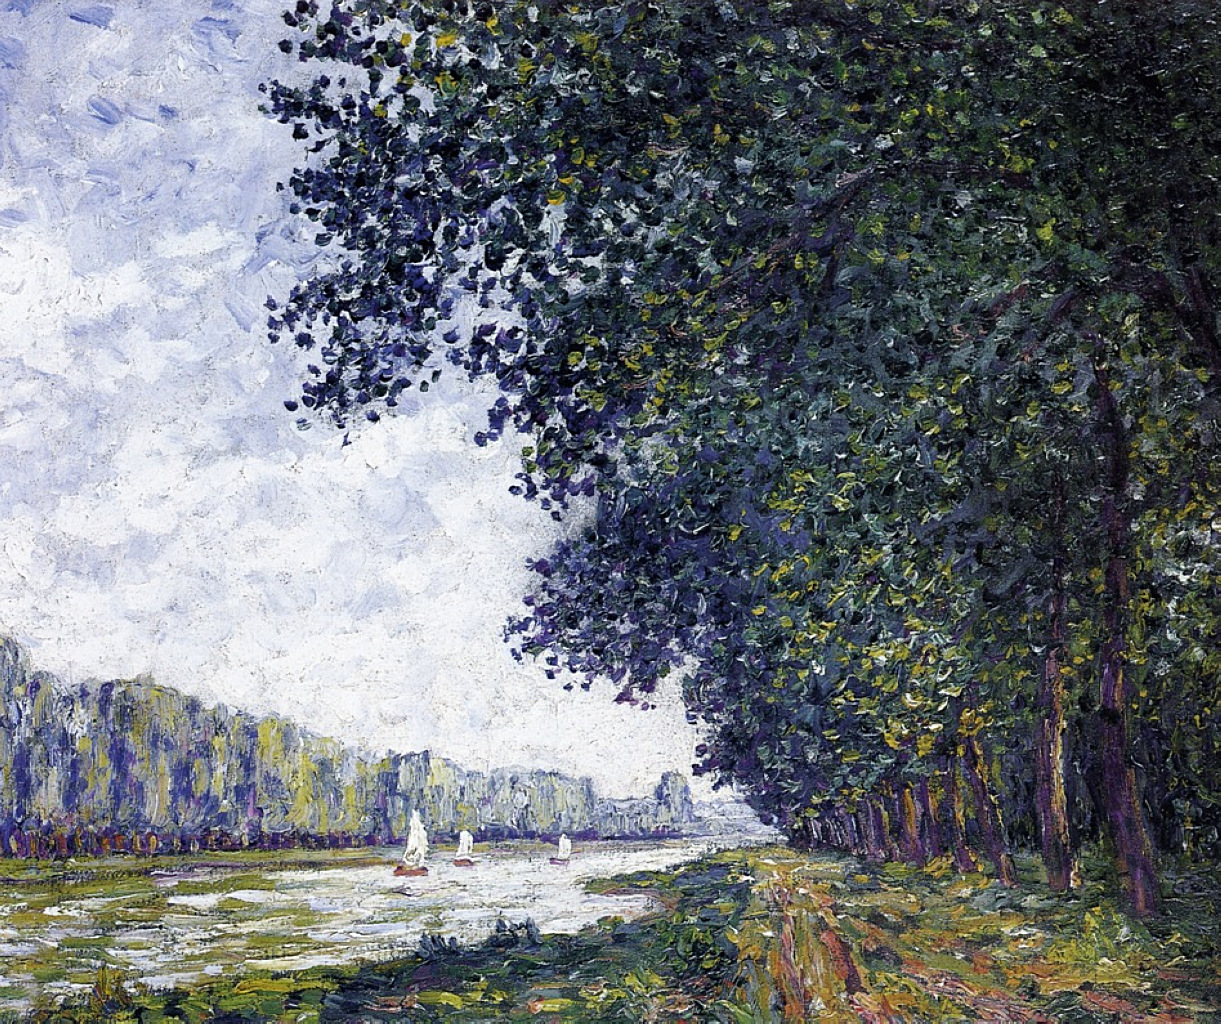What could be the artist's inspiration for this piece? The artist’s inspiration for this piece could stem from a deep appreciation for the serene beauty of nature. Observing the play of light on the water, the rich textures of the foliage, and the gentle motion of the sailboats might have sparked a desire to capture these fleeting moments in paint. The artist could also have been inspired by personal experiences, perhaps recalling peaceful walks along riverbanks or tranquil afternoons spent observing the natural world. Such scenes provide a profound sense of tranquility and contemplation, which the artist sought to immortalize through their work. Paint a vivid story of a day spent along this river using highly creative imagery. In a dreamy, watercolor dawn, the river awakens with the whispers of the breeze tickling its glassy surface. The first rays of sunlight paint the sky in hues of pink and gold, as a lone fisherman casts his line, hoping for the day's first catch. The trees along the riverbank, ancient sentinels of time, rustle their leaves in a morning symphony, singing of stories untold. A group of children, armed with nets and boundless curiosity, chase after tadpoles in the shallow waters, their laughter echoing like bells in the still air. As the day unfurls, picnickers lay out checkered blankets, their baskets brimming with freshly baked bread and sun-ripened fruits, sharing stories and dreams under the shade of the great oaks. Sailboats glide gracefully, their white sails billowing against the cerulean sky, a ballet of elegance and freedom. As the sun dips towards the horizon, casting a golden glow, the river becomes a ribbon of fire, reflecting the day's end. The scene is filled with the small, precious moments that make up the tapestry of life, each thread shimmering with joy and tranquility. 